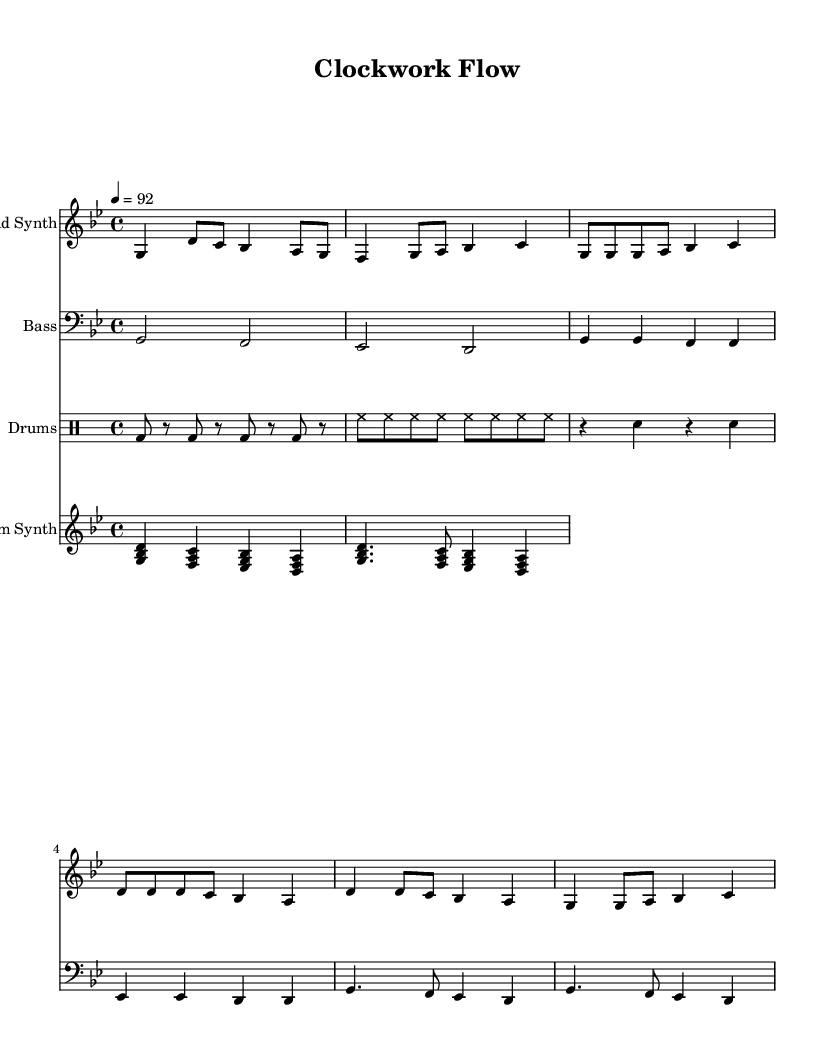What is the key signature of this music? The key signature is G minor, which has two flats (B flat and E flat). This information can be deduced from the arrangement of the notes in the sheet music.
Answer: G minor What is the time signature of this music? The time signature is 4/4, as indicated at the beginning of the piece. This means there are four beats in a measure, and the quarter note gets one beat.
Answer: 4/4 What is the tempo marking in BPM? The tempo marking indicates a speed of 92 beats per minute. This is specified above the staff as a tempo indication, helping musicians to know how quickly to perform the piece.
Answer: 92 How many measures are in the lead synth part? The lead synth part consists of 6 measures. By visually counting each group of notes separated by vertical lines on the staff, we can determine this.
Answer: 6 Which instrument plays the rhythm synth? The rhythm synth is played by a staff labeled as "Rhythm Synth." The label clearly identifies the instrument associated with that staff in the sheet music.
Answer: Rhythm Synth What is the function of the drum pattern in this piece? The drum pattern serves as a foundational rhythmic element, providing a consistent tempo and helping to drive the music forward. This is typical in hip hop music where drums are essential for establishing the groove.
Answer: Foundation How does the bass line contribute to the overall feel of the song? The bass line provides depth and complements the rhythm, creating a sense of grounding in the music. In hip hop, the bass often emphasizes the beat and supports the lyrical flow, enhancing the overall vibe of the piece.
Answer: Depth 